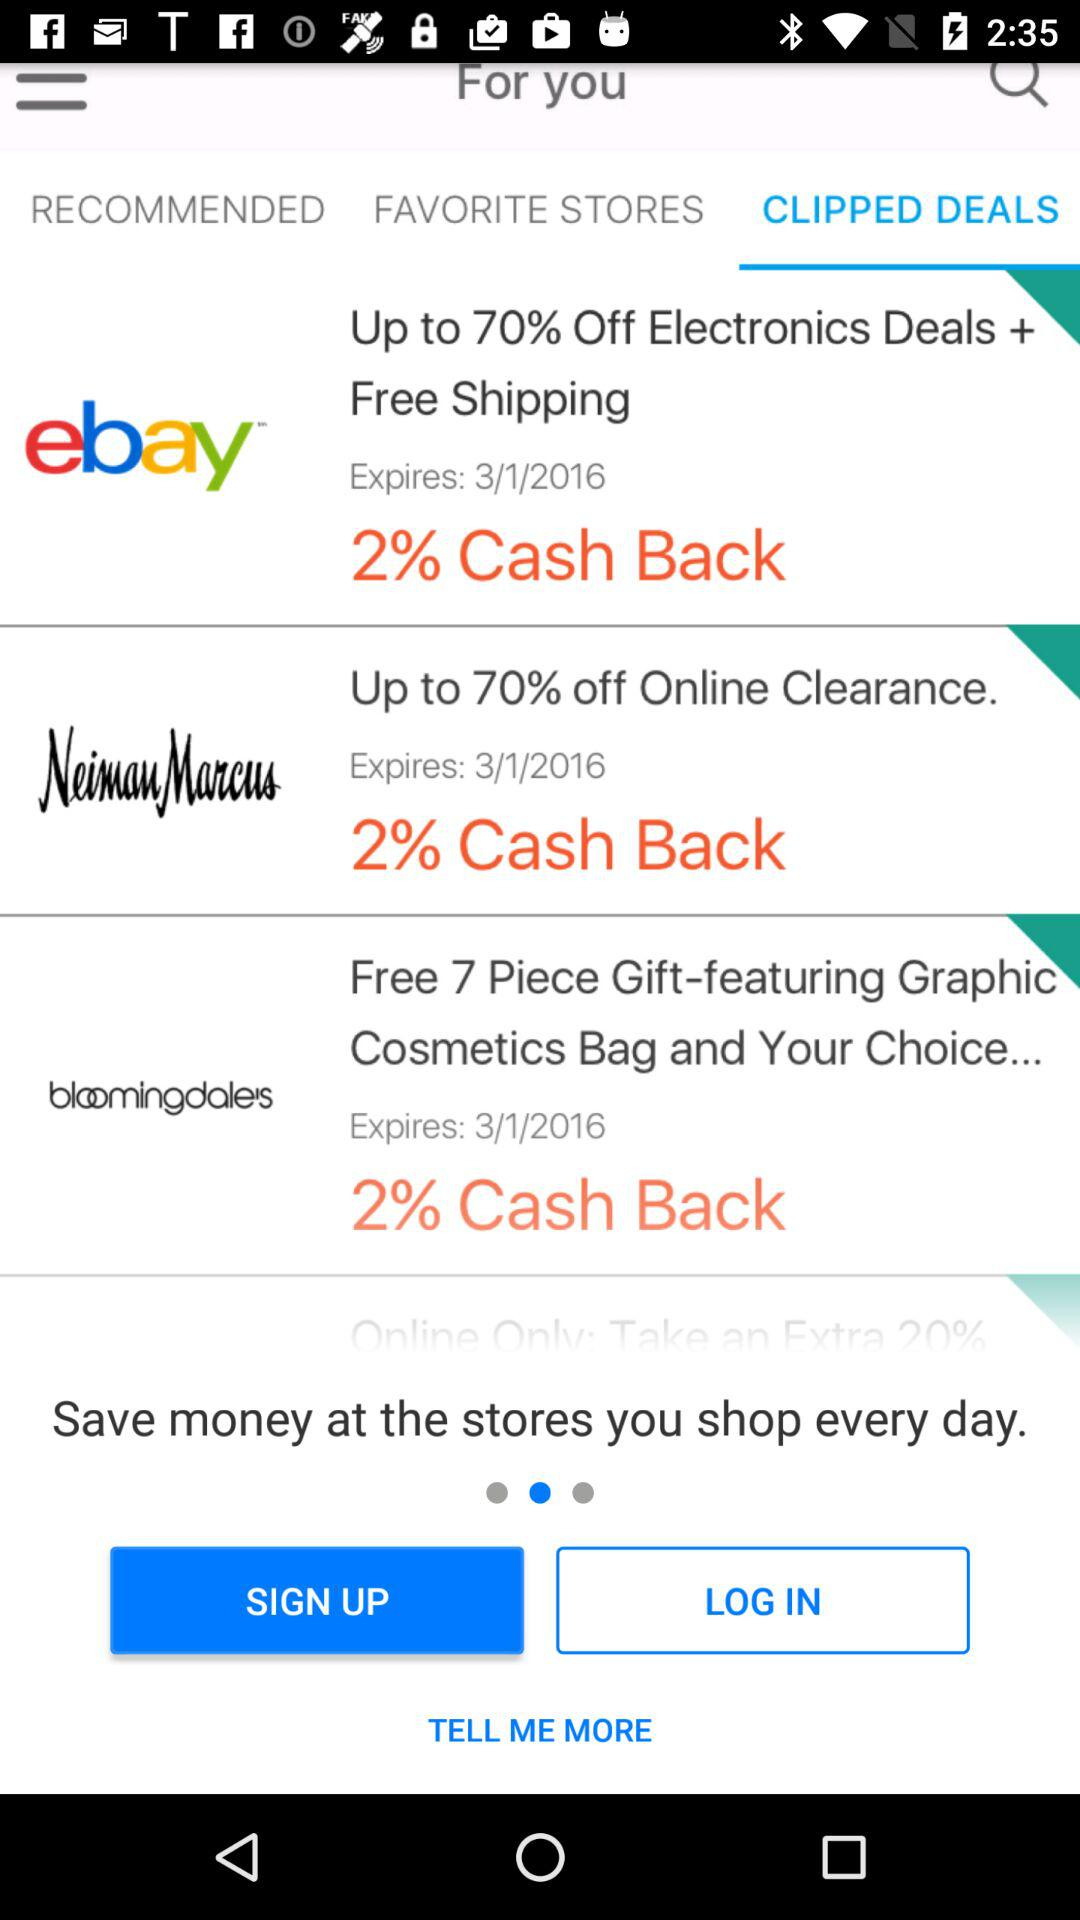How many deals are from Neiman Marcus?
Answer the question using a single word or phrase. 1 